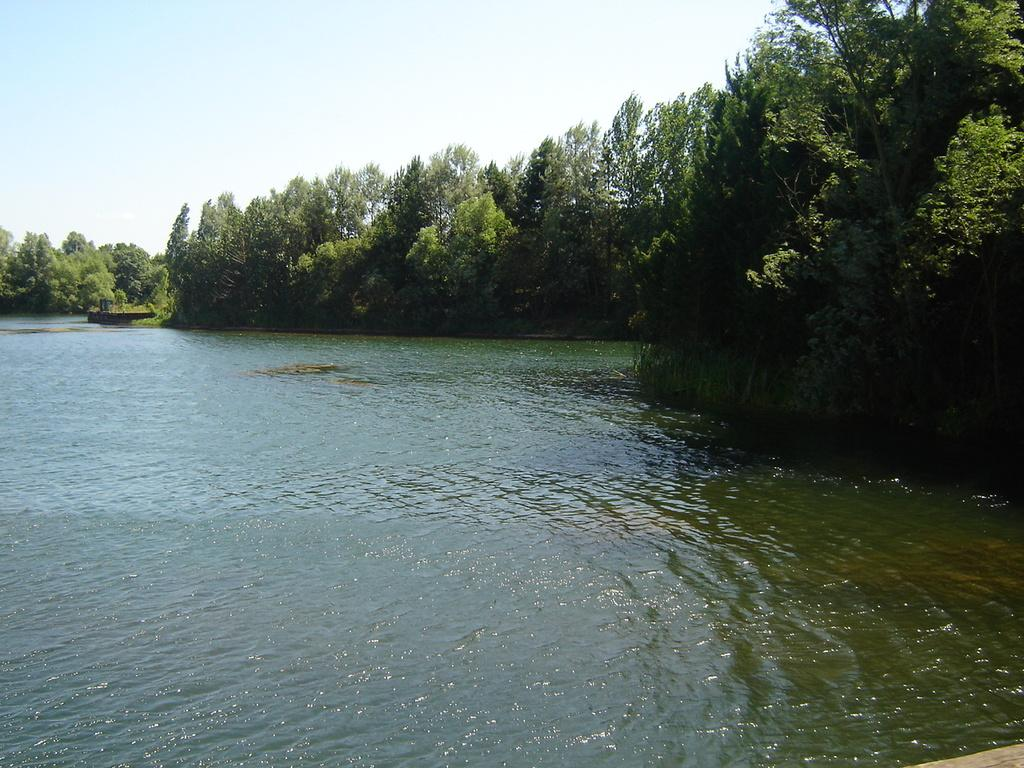What is the primary element visible in the image? There is water in the image. What type of vegetation can be seen in the image? There are trees in the front of the image. What part of the natural environment is visible in the background of the image? The sky is visible in the background of the image. What type of scarf is being used by the thing in the image? There is no scarf or thing present in the image; it features water, trees, and the sky. 